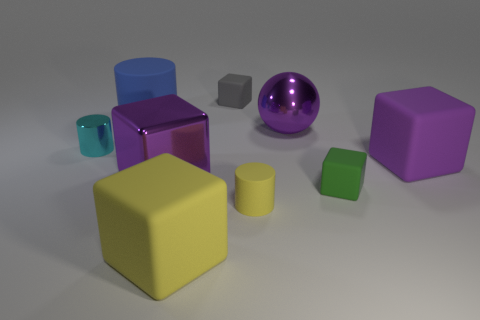What number of spheres are either purple rubber objects or small shiny objects? Upon examination of the image, there is one sphere that appears to be a shiny purple object. However, the specific materials of the objects are not discernable from the image alone without additional contextual information. Assuming the shiny appearance implies the 'rubber' quality, then the answer would be one sphere matching the description. 